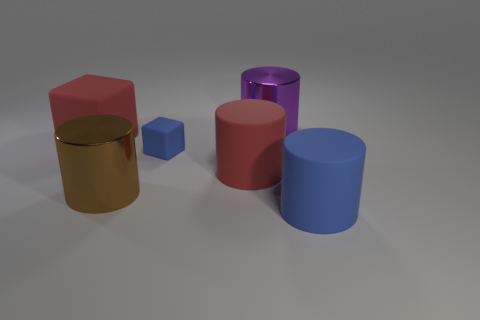Subtract 1 cylinders. How many cylinders are left? 3 Add 3 yellow cubes. How many objects exist? 9 Subtract all cubes. How many objects are left? 4 Subtract all large cyan blocks. Subtract all small blue objects. How many objects are left? 5 Add 5 large metallic cylinders. How many large metallic cylinders are left? 7 Add 3 tiny blue blocks. How many tiny blue blocks exist? 4 Subtract 0 purple spheres. How many objects are left? 6 